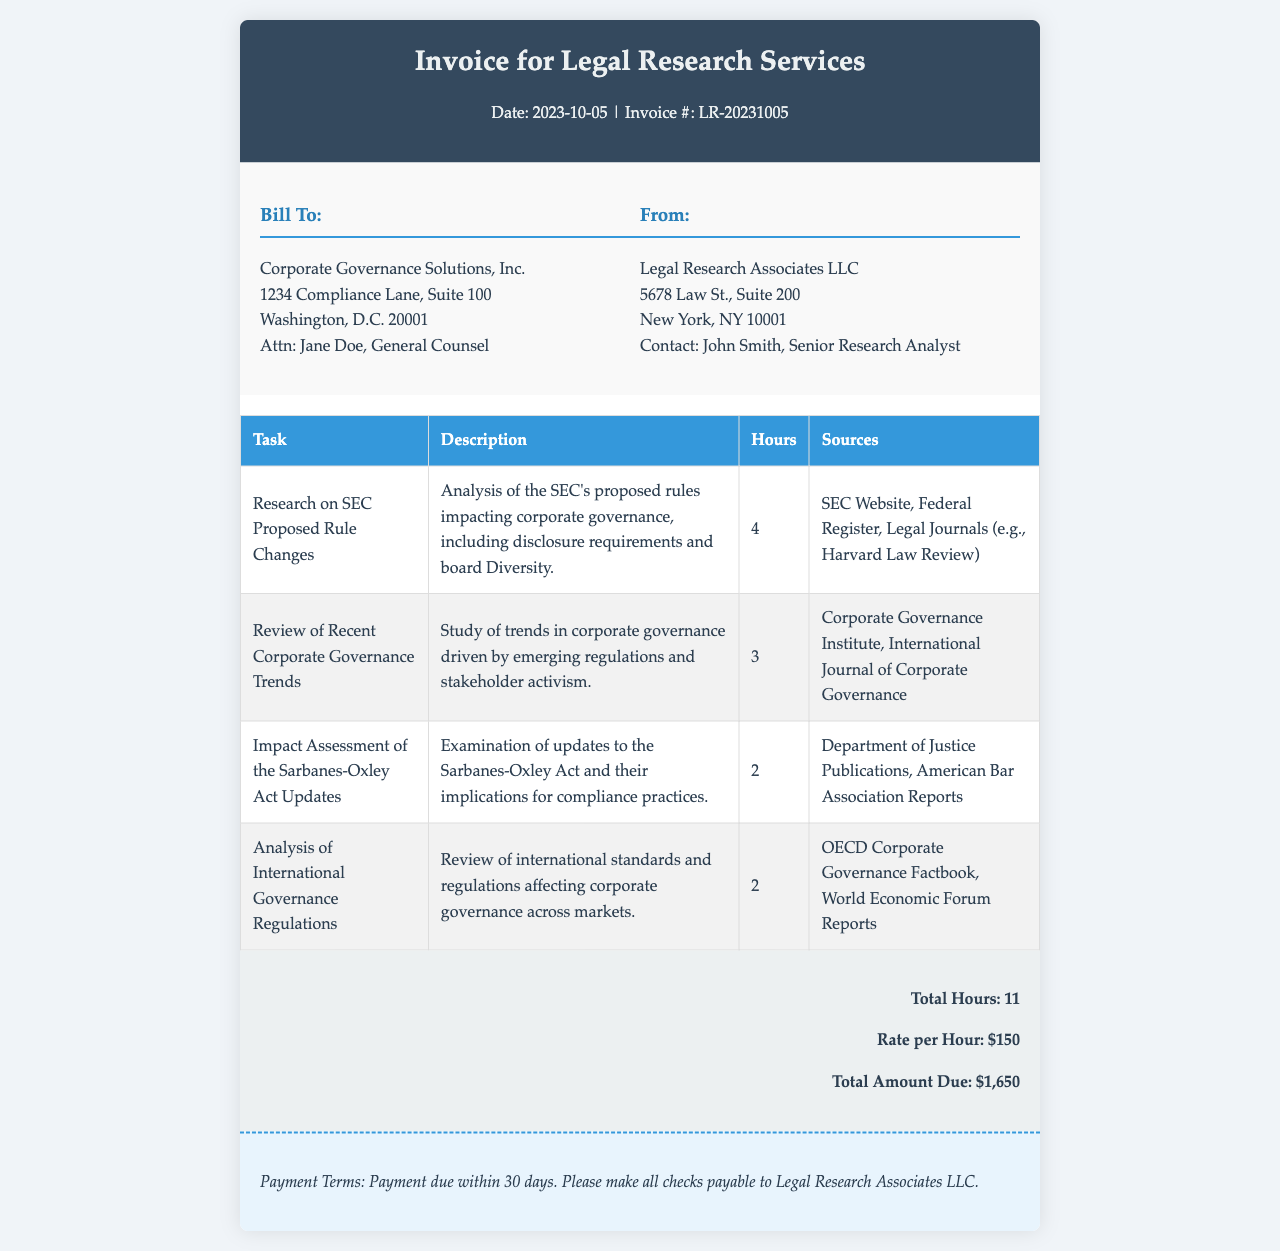What is the invoice number? The invoice number is explicitly mentioned in the document as LR-20231005.
Answer: LR-20231005 Who is the billed entity? The document lists the billed entity as Corporate Governance Solutions, Inc.
Answer: Corporate Governance Solutions, Inc How many total hours of research were conducted? The total hours are calculated based on the breakdown in the document, which sums to 11 hours.
Answer: 11 What is the rate per hour for the services? The rate per hour is stated in the document and is $150.
Answer: $150 What is the total amount due? The document specifies that the total amount due is calculated as $1,650.
Answer: $1,650 Which sources were consulted for the SEC Proposed Rule Changes? The document lists the SEC Website, Federal Register, and Legal Journals as the consulted sources.
Answer: SEC Website, Federal Register, Legal Journals What task accounts for the most hours in the research? The task "Research on SEC Proposed Rule Changes" accounts for 4 hours, which is the highest among listed tasks.
Answer: Research on SEC Proposed Rule Changes What are the payment terms mentioned in the invoice? The payment terms specify that payment is due within 30 days.
Answer: Payment due within 30 days Which entity is providing the legal research services? The document indicates that Legal Research Associates LLC is providing the services.
Answer: Legal Research Associates LLC 